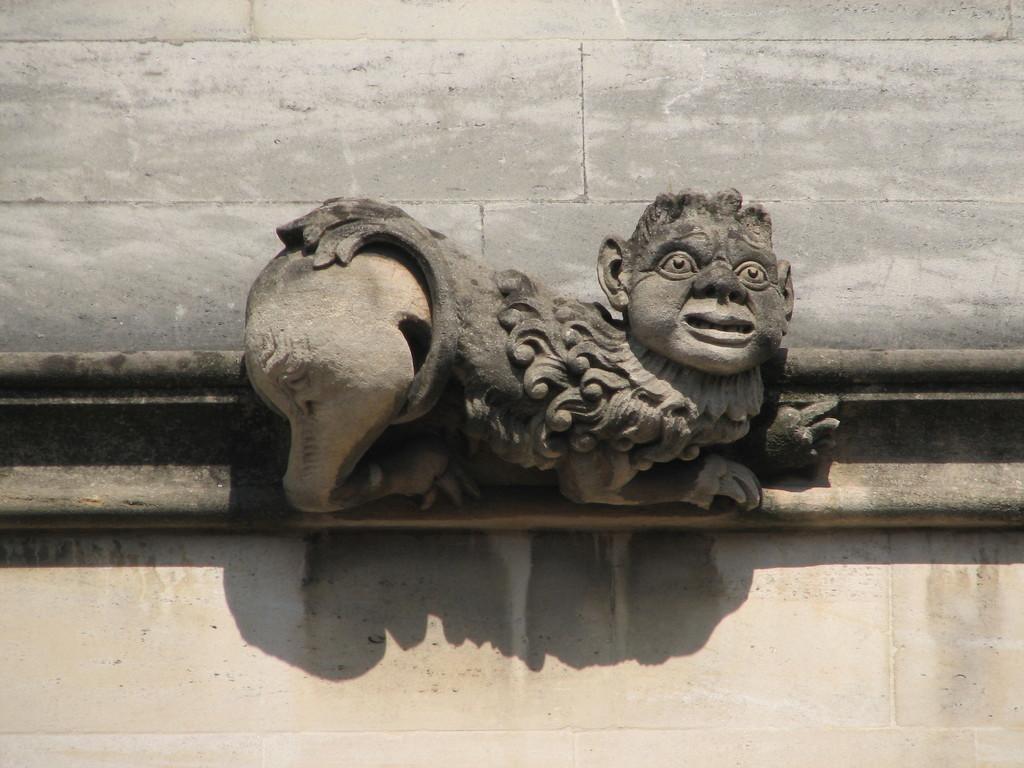Could you give a brief overview of what you see in this image? In the center of the picture there is a sculpture. At the top there is a brick wall. At the bottom it is well. In the picture it is sunny. 